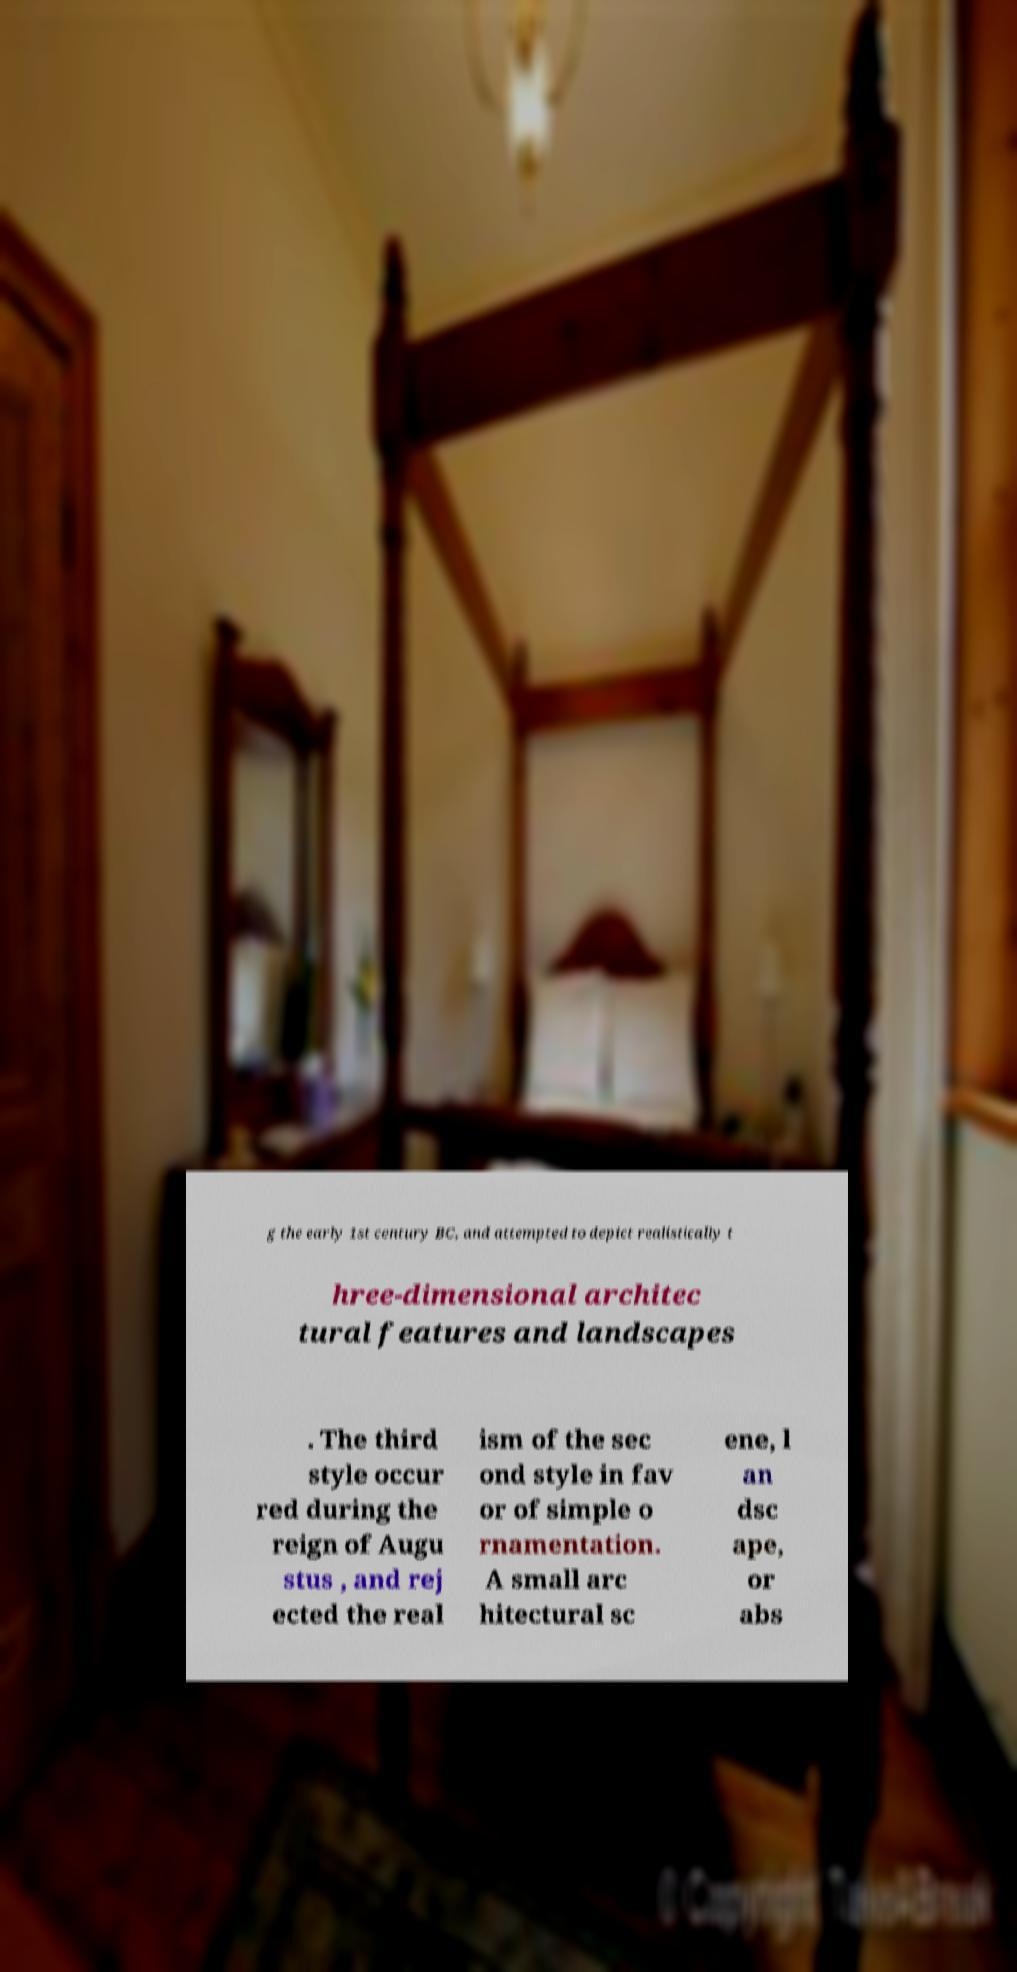What messages or text are displayed in this image? I need them in a readable, typed format. g the early 1st century BC, and attempted to depict realistically t hree-dimensional architec tural features and landscapes . The third style occur red during the reign of Augu stus , and rej ected the real ism of the sec ond style in fav or of simple o rnamentation. A small arc hitectural sc ene, l an dsc ape, or abs 